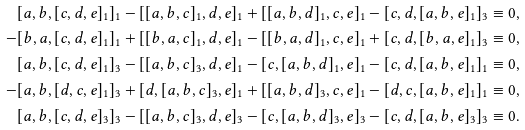Convert formula to latex. <formula><loc_0><loc_0><loc_500><loc_500>[ a , b , [ c , d , e ] _ { 1 } ] _ { 1 } - [ [ a , b , c ] _ { 1 } , d , e ] _ { 1 } + [ [ a , b , d ] _ { 1 } , c , e ] _ { 1 } - [ c , d , [ a , b , e ] _ { 1 } ] _ { 3 } & \equiv 0 , \\ - [ b , a , [ c , d , e ] _ { 1 } ] _ { 1 } + [ [ b , a , c ] _ { 1 } , d , e ] _ { 1 } - [ [ b , a , d ] _ { 1 } , c , e ] _ { 1 } + [ c , d , [ b , a , e ] _ { 1 } ] _ { 3 } & \equiv 0 , \\ [ a , b , [ c , d , e ] _ { 1 } ] _ { 3 } - [ [ a , b , c ] _ { 3 } , d , e ] _ { 1 } - [ c , [ a , b , d ] _ { 1 } , e ] _ { 1 } - [ c , d , [ a , b , e ] _ { 1 } ] _ { 1 } & \equiv 0 , \\ - [ a , b , [ d , c , e ] _ { 1 } ] _ { 3 } + [ d , [ a , b , c ] _ { 3 } , e ] _ { 1 } + [ [ a , b , d ] _ { 3 } , c , e ] _ { 1 } - [ d , c , [ a , b , e ] _ { 1 } ] _ { 1 } & \equiv 0 , \\ [ a , b , [ c , d , e ] _ { 3 } ] _ { 3 } - [ [ a , b , c ] _ { 3 } , d , e ] _ { 3 } - [ c , [ a , b , d ] _ { 3 } , e ] _ { 3 } - [ c , d , [ a , b , e ] _ { 3 } ] _ { 3 } & \equiv 0 .</formula> 